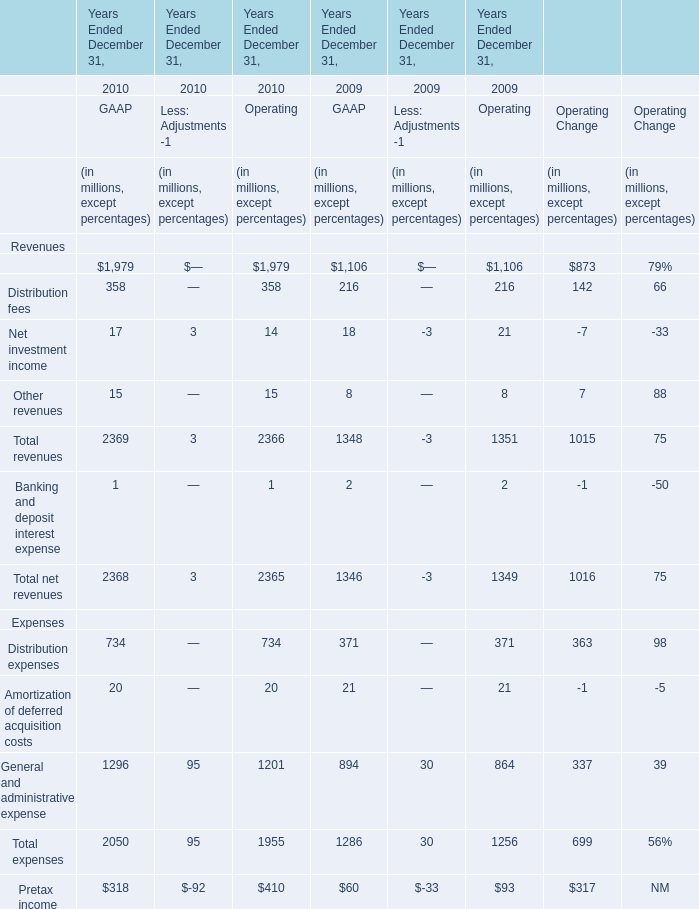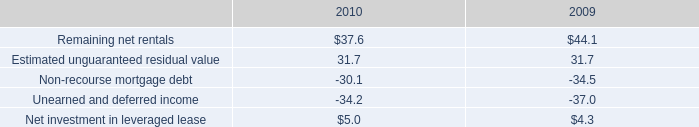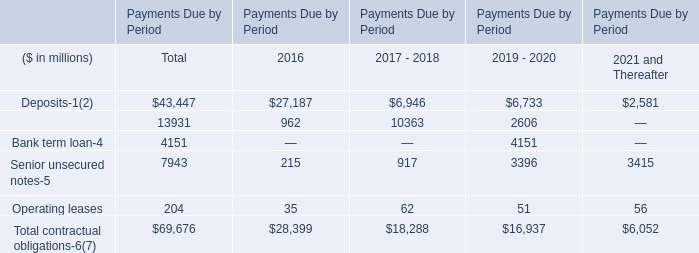What is the proportion of distribution fees of GAAP to the total revenues of GAAP in 2010? 
Computations: (358 / 2369)
Answer: 0.15112. 